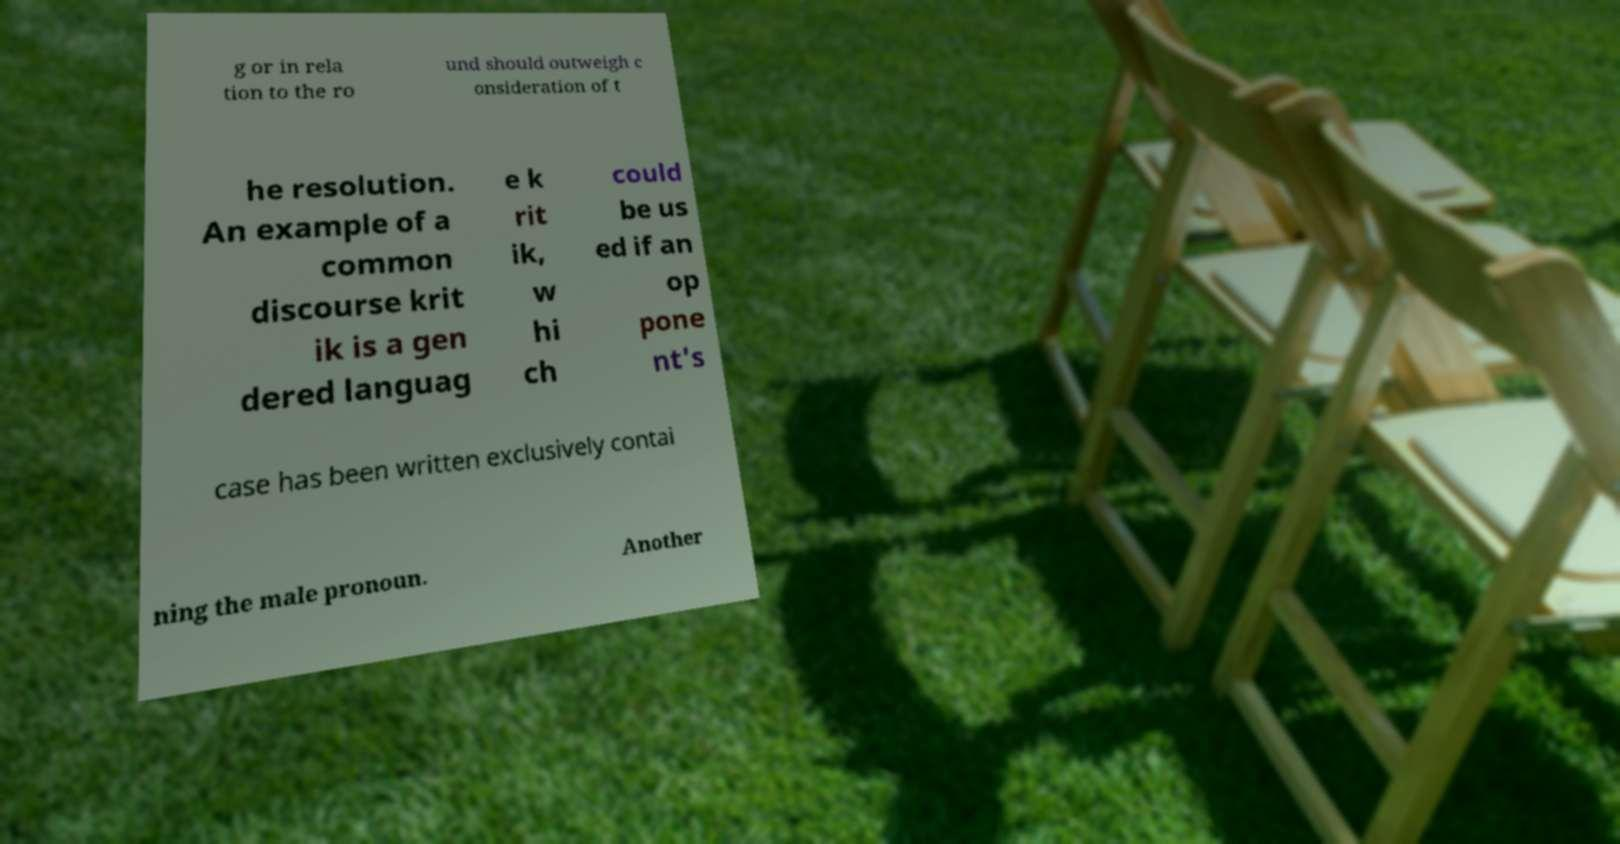Can you accurately transcribe the text from the provided image for me? g or in rela tion to the ro und should outweigh c onsideration of t he resolution. An example of a common discourse krit ik is a gen dered languag e k rit ik, w hi ch could be us ed if an op pone nt's case has been written exclusively contai ning the male pronoun. Another 